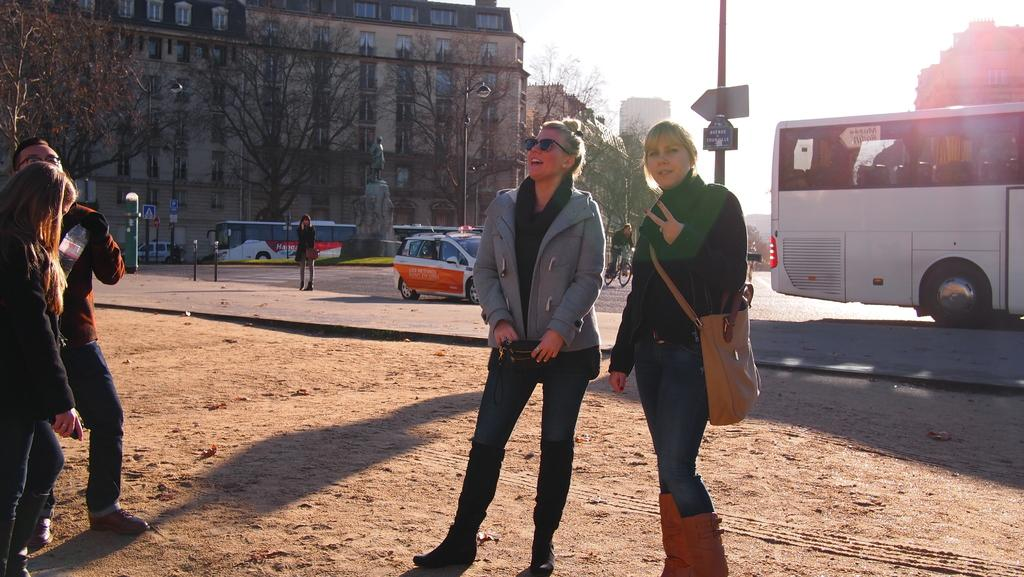How many people are in the image? There is a group of people in the image, but the exact number is not specified. What else can be seen in the image besides the group of people? There are vehicles, trees, poles, sign boards, a statue, and buildings in the background of the image. Can you describe the background of the image? The background of the image includes trees, poles, sign boards, a statue, and buildings. What might the sign boards be used for? The sign boards in the background of the image might be used for providing information or directions. What songs is the dad singing in the image? There is no dad or any indication of singing in the image. 